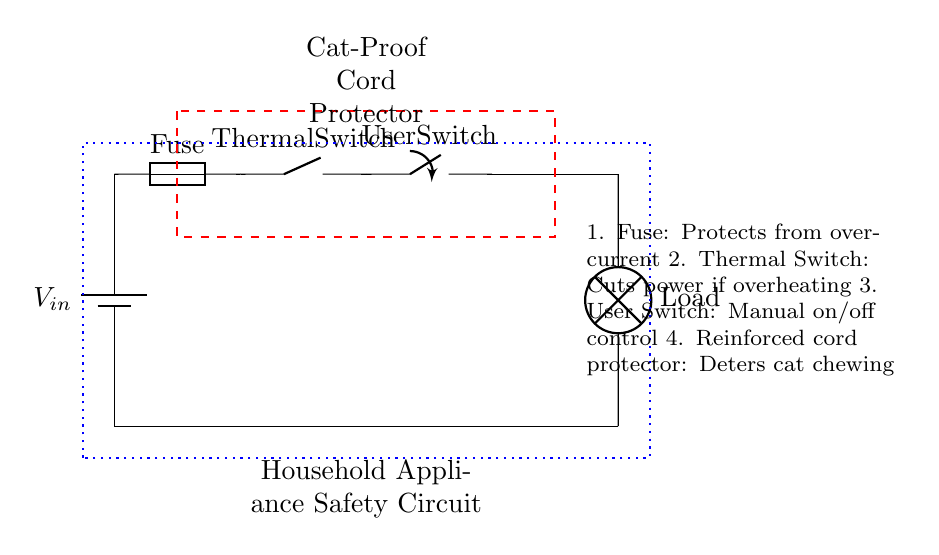What is the input voltage of the circuit? The input voltage is designated as Vin, which is typically the supplied voltage for the entire circuit.
Answer: Vin What is the function of the fuse in this circuit? The fuse is designed to protect the circuit from overcurrent conditions by breaking the circuit if the current exceeds a safe level.
Answer: Protects from overcurrent What is the purpose of the thermal switch? The thermal switch cuts power to the circuit if it detects overheating, which prevents potential fire hazards.
Answer: Cuts power if overheating How many main components are present in the circuit? Counting the components: there are a battery, a fuse, a thermal switch, a user switch, and a load, adding up to five main components.
Answer: Five Which component provides manual control of the circuit? The user switch allows the user to manually turn the circuit on or off, giving control over the operation.
Answer: User Switch What is the role of the reinforced cord protector? The reinforced cord protector is designed specifically to deter cats from chewing on the electrical cord, thereby enhancing safety.
Answer: Deters cat chewing What happens if the fuse blows in this circuit? If the fuse blows, it interrupts the circuit, stopping current flow and preventing potential damage or hazards to the circuit components.
Answer: Stops current flow 